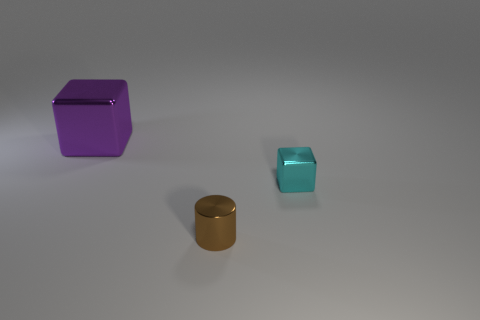Add 1 big matte cylinders. How many objects exist? 4 Subtract all cylinders. How many objects are left? 2 Add 1 cyan shiny blocks. How many cyan shiny blocks are left? 2 Add 3 purple blocks. How many purple blocks exist? 4 Subtract 0 cyan spheres. How many objects are left? 3 Subtract all small cyan metallic blocks. Subtract all small objects. How many objects are left? 0 